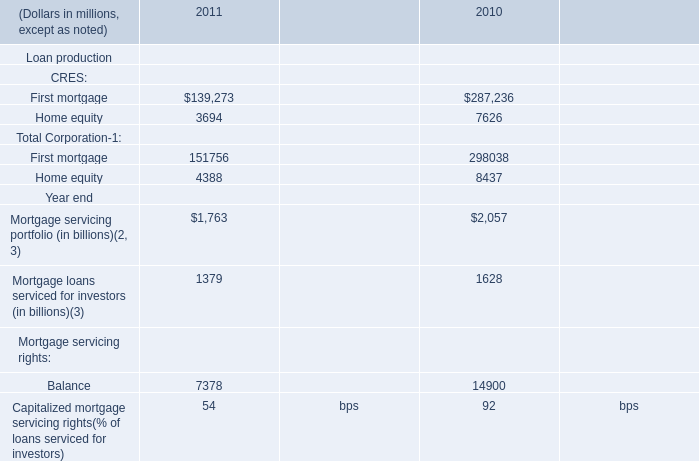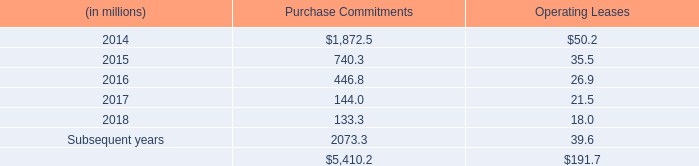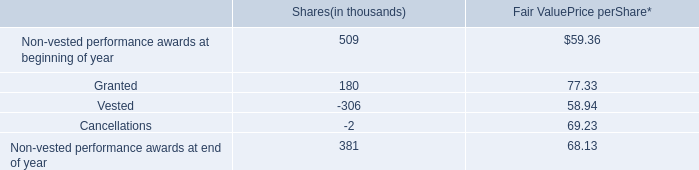Which year is Home equity of CRES the least? 
Answer: 2011. 